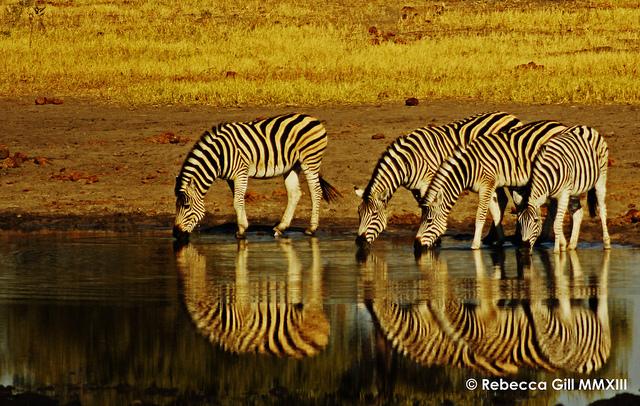What does the reflection show?
Concise answer only. Zebras. Are these zebras thirsty?
Write a very short answer. Yes. How many zebras are there?
Quick response, please. 4. 